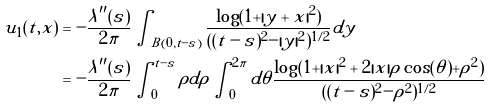<formula> <loc_0><loc_0><loc_500><loc_500>u _ { 1 } ( t , x ) & = - \frac { \lambda ^ { \prime \prime } ( s ) } { 2 \pi } \int _ { B ( 0 , t - s ) } \frac { \log ( 1 + | y + x | ^ { 2 } ) } { ( ( t - s ) ^ { 2 } - | y | ^ { 2 } ) ^ { 1 / 2 } } d y \\ & = - \frac { \lambda ^ { \prime \prime } ( s ) } { 2 \pi } \int _ { 0 } ^ { t - s } \rho d \rho \int _ { 0 } ^ { 2 \pi } d \theta \frac { \log ( 1 + | x | ^ { 2 } + 2 | x | \rho \cos ( \theta ) + \rho ^ { 2 } ) } { ( ( t - s ) ^ { 2 } - \rho ^ { 2 } ) ^ { 1 / 2 } }</formula> 